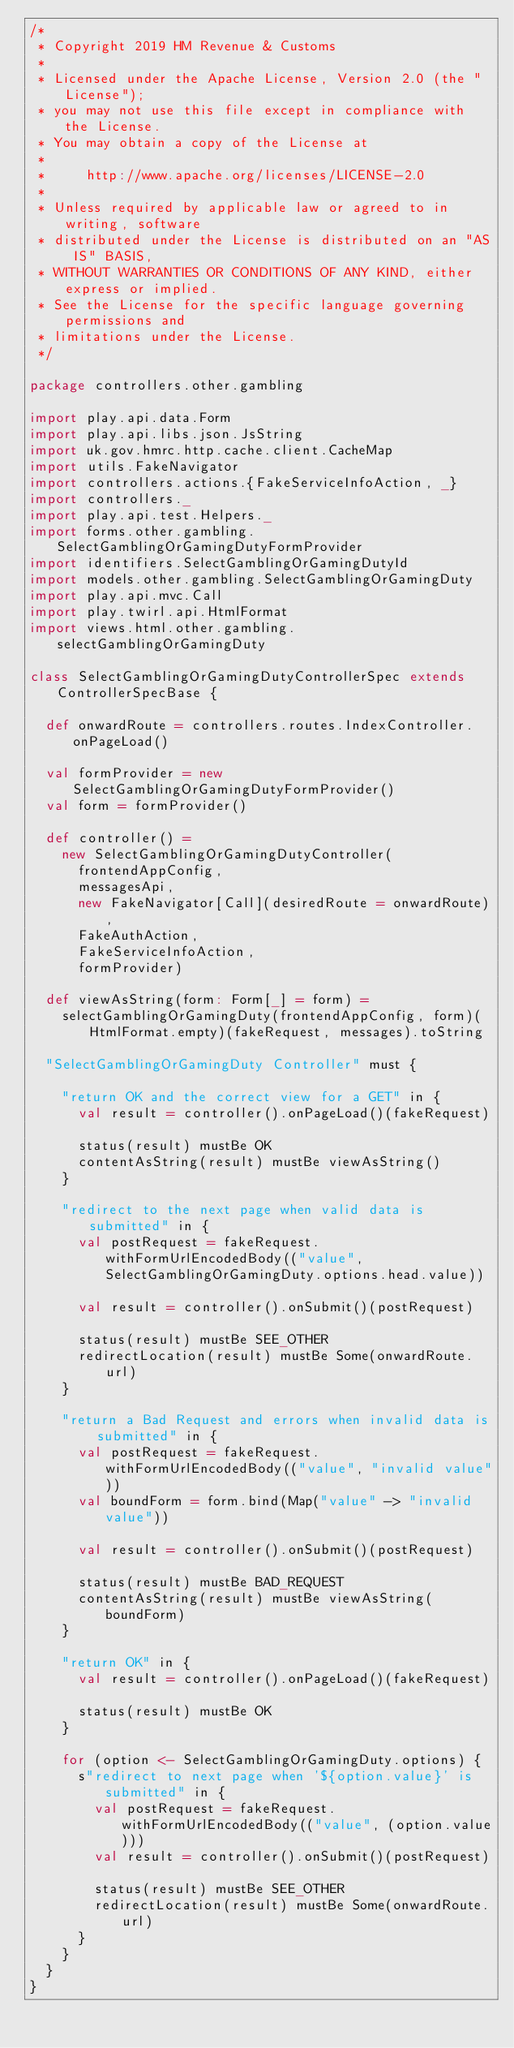Convert code to text. <code><loc_0><loc_0><loc_500><loc_500><_Scala_>/*
 * Copyright 2019 HM Revenue & Customs
 *
 * Licensed under the Apache License, Version 2.0 (the "License");
 * you may not use this file except in compliance with the License.
 * You may obtain a copy of the License at
 *
 *     http://www.apache.org/licenses/LICENSE-2.0
 *
 * Unless required by applicable law or agreed to in writing, software
 * distributed under the License is distributed on an "AS IS" BASIS,
 * WITHOUT WARRANTIES OR CONDITIONS OF ANY KIND, either express or implied.
 * See the License for the specific language governing permissions and
 * limitations under the License.
 */

package controllers.other.gambling

import play.api.data.Form
import play.api.libs.json.JsString
import uk.gov.hmrc.http.cache.client.CacheMap
import utils.FakeNavigator
import controllers.actions.{FakeServiceInfoAction, _}
import controllers._
import play.api.test.Helpers._
import forms.other.gambling.SelectGamblingOrGamingDutyFormProvider
import identifiers.SelectGamblingOrGamingDutyId
import models.other.gambling.SelectGamblingOrGamingDuty
import play.api.mvc.Call
import play.twirl.api.HtmlFormat
import views.html.other.gambling.selectGamblingOrGamingDuty

class SelectGamblingOrGamingDutyControllerSpec extends ControllerSpecBase {

  def onwardRoute = controllers.routes.IndexController.onPageLoad()

  val formProvider = new SelectGamblingOrGamingDutyFormProvider()
  val form = formProvider()

  def controller() =
    new SelectGamblingOrGamingDutyController(
      frontendAppConfig,
      messagesApi,
      new FakeNavigator[Call](desiredRoute = onwardRoute),
      FakeAuthAction,
      FakeServiceInfoAction,
      formProvider)

  def viewAsString(form: Form[_] = form) =
    selectGamblingOrGamingDuty(frontendAppConfig, form)(HtmlFormat.empty)(fakeRequest, messages).toString

  "SelectGamblingOrGamingDuty Controller" must {

    "return OK and the correct view for a GET" in {
      val result = controller().onPageLoad()(fakeRequest)

      status(result) mustBe OK
      contentAsString(result) mustBe viewAsString()
    }

    "redirect to the next page when valid data is submitted" in {
      val postRequest = fakeRequest.withFormUrlEncodedBody(("value", SelectGamblingOrGamingDuty.options.head.value))

      val result = controller().onSubmit()(postRequest)

      status(result) mustBe SEE_OTHER
      redirectLocation(result) mustBe Some(onwardRoute.url)
    }

    "return a Bad Request and errors when invalid data is submitted" in {
      val postRequest = fakeRequest.withFormUrlEncodedBody(("value", "invalid value"))
      val boundForm = form.bind(Map("value" -> "invalid value"))

      val result = controller().onSubmit()(postRequest)

      status(result) mustBe BAD_REQUEST
      contentAsString(result) mustBe viewAsString(boundForm)
    }

    "return OK" in {
      val result = controller().onPageLoad()(fakeRequest)

      status(result) mustBe OK
    }

    for (option <- SelectGamblingOrGamingDuty.options) {
      s"redirect to next page when '${option.value}' is submitted" in {
        val postRequest = fakeRequest.withFormUrlEncodedBody(("value", (option.value)))
        val result = controller().onSubmit()(postRequest)

        status(result) mustBe SEE_OTHER
        redirectLocation(result) mustBe Some(onwardRoute.url)
      }
    }
  }
}
</code> 